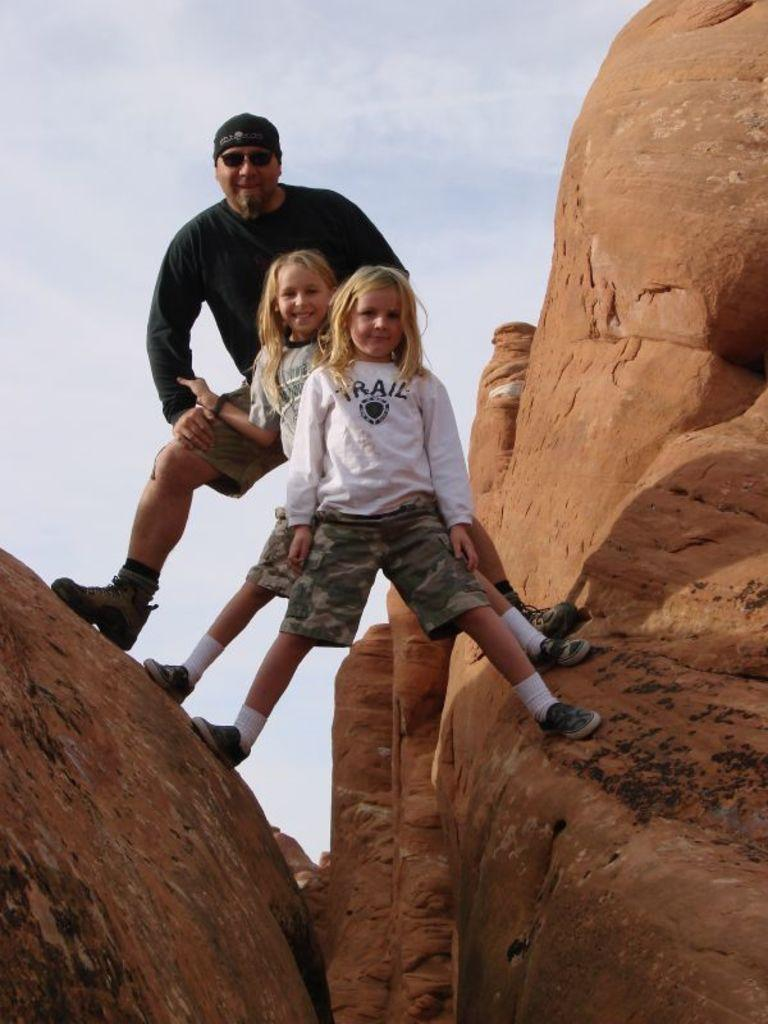Who is present in the image? There is a man and two girls in the image. Where are the man and girls located? They are on hills in the image. What can be seen at the top of the image? The sky is visible at the top of the image. What type of yam is being harvested by the parent in the image? There is no yam or parent present in the image. What type of field can be seen in the background of the image? There is no field visible in the image; it features hills and a sky. 